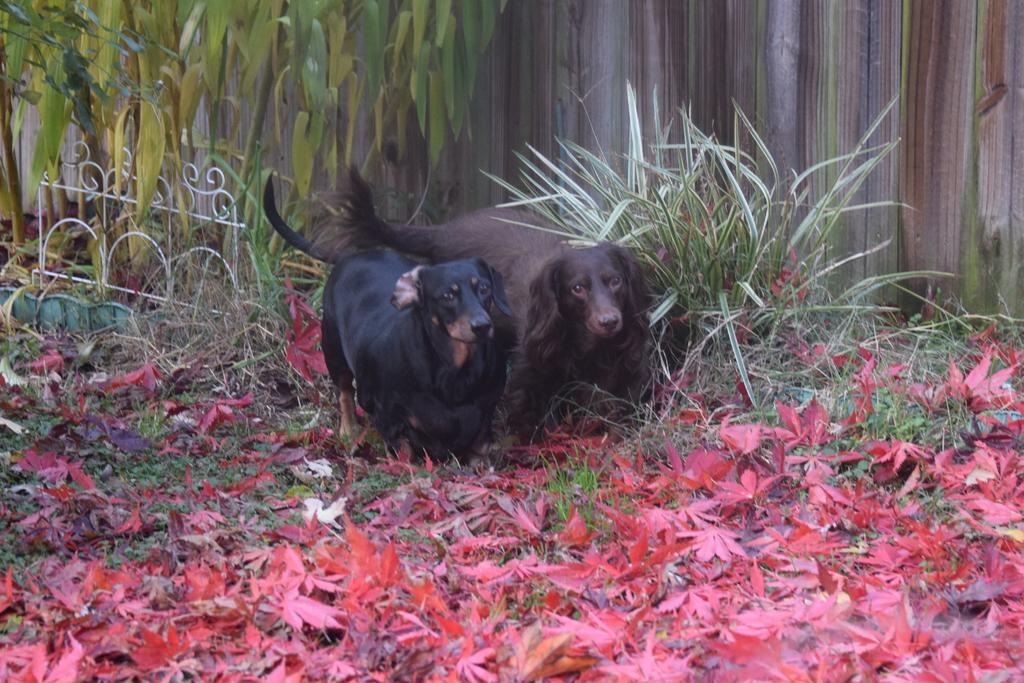How many dogs are present in the image? There are two dogs in the image. What are the dogs doing in the image? The dogs are looking at someone. What can be seen on the ground in the image? There are many leaves on the ground in the image. What type of metal is the zephyr made of in the image? There is no zephyr or metal present in the image; it features two dogs looking at someone with leaves on the ground. 